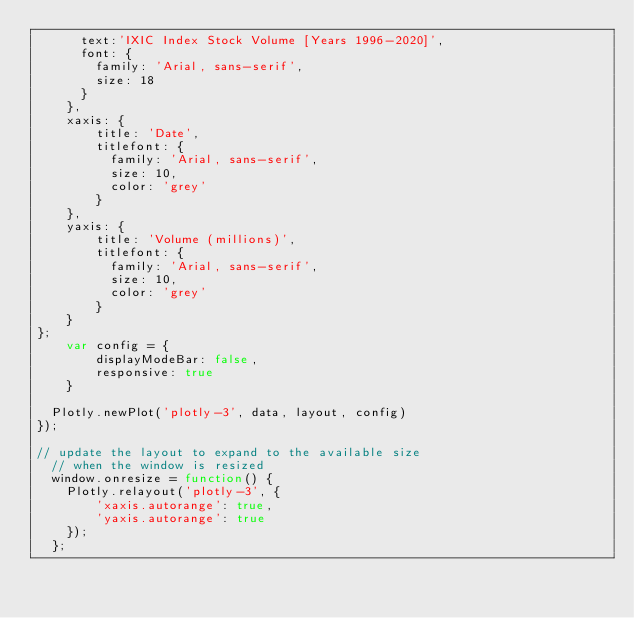Convert code to text. <code><loc_0><loc_0><loc_500><loc_500><_JavaScript_>      text:'IXIC Index Stock Volume [Years 1996-2020]',
      font: {
        family: 'Arial, sans-serif',
        size: 18
      }
    },
    xaxis: {
        title: 'Date',
        titlefont: {
          family: 'Arial, sans-serif',
          size: 10,
          color: 'grey'
        }
    },
    yaxis: {
        title: 'Volume (millions)',
        titlefont: {
          family: 'Arial, sans-serif',
          size: 10,
          color: 'grey'
        }
    }
};
    var config = {
        displayModeBar: false,
        responsive: true
    }
  
  Plotly.newPlot('plotly-3', data, layout, config)
});

// update the layout to expand to the available size
  // when the window is resized
  window.onresize = function() {
    Plotly.relayout('plotly-3', {
        'xaxis.autorange': true,
        'yaxis.autorange': true
    });
  };
</code> 